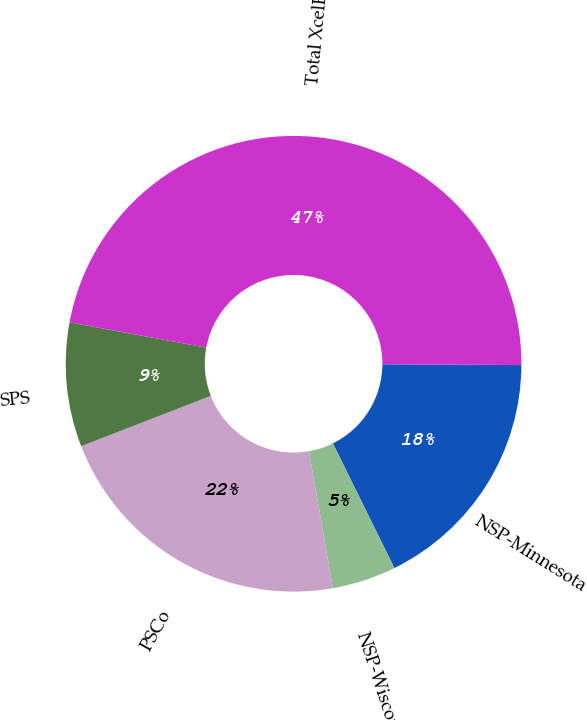Convert chart to OTSL. <chart><loc_0><loc_0><loc_500><loc_500><pie_chart><fcel>NSP-Minnesota<fcel>NSP-Wisconsin<fcel>PSCo<fcel>SPS<fcel>Total XcelEnergy<nl><fcel>17.61%<fcel>4.53%<fcel>21.87%<fcel>8.8%<fcel>47.18%<nl></chart> 